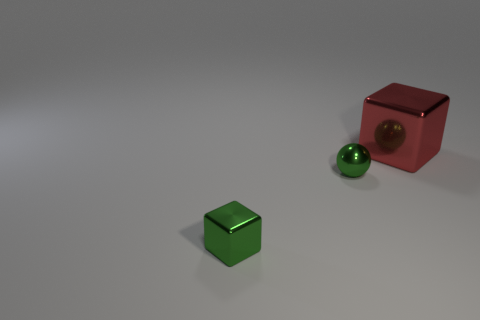Is the color of the small metal block the same as the tiny shiny object that is behind the green metal cube?
Give a very brief answer. Yes. What is the material of the small ball that is the same color as the small block?
Provide a succinct answer. Metal. There is a green metallic sphere; what number of large red shiny cubes are in front of it?
Your answer should be compact. 0. Does the thing that is right of the green metallic sphere have the same shape as the green metallic object that is left of the small green sphere?
Provide a short and direct response. Yes. What number of other things are the same color as the big thing?
Your response must be concise. 0. The block that is to the left of the large red block behind the cube in front of the red thing is made of what material?
Make the answer very short. Metal. Are there fewer blocks that are to the right of the small green cube than green cubes?
Make the answer very short. No. There is a green object behind the small cube; what shape is it?
Your answer should be very brief. Sphere. There is a sphere; does it have the same size as the metal cube behind the small green block?
Provide a succinct answer. No. Are there any green things made of the same material as the red thing?
Your answer should be compact. Yes. 